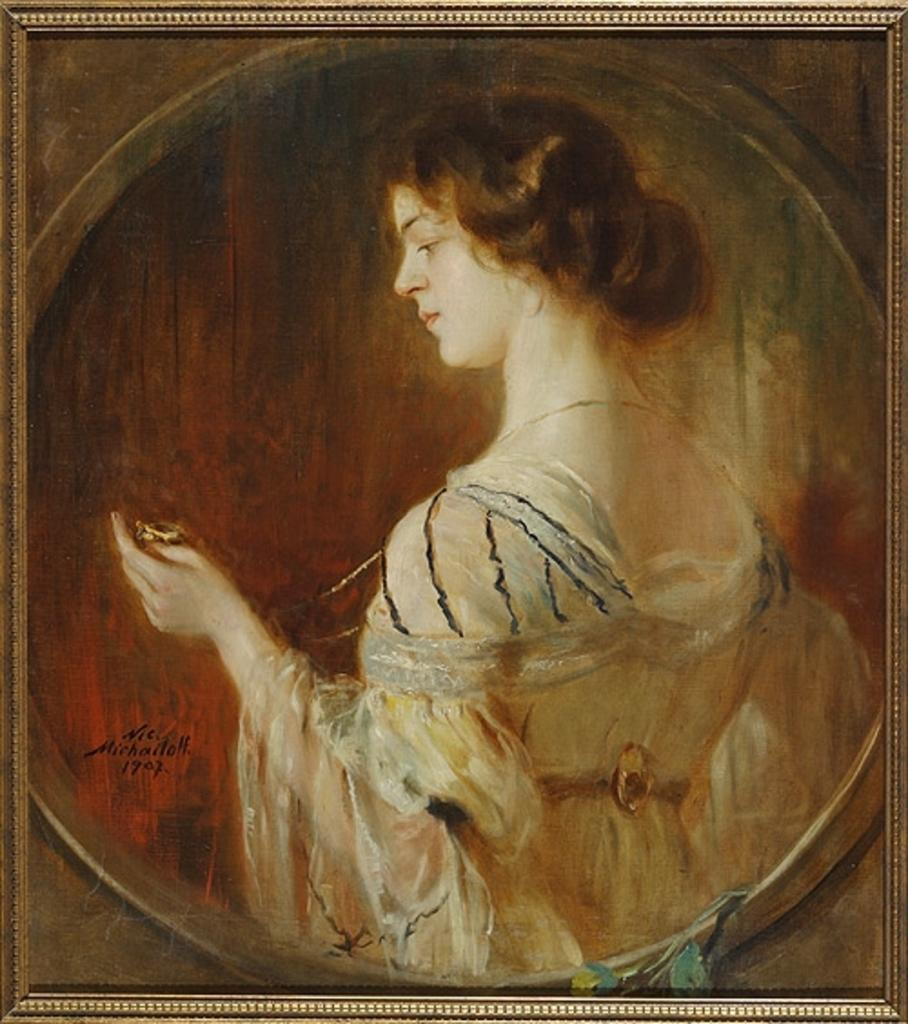What object is present in the image that typically holds a picture or artwork? There is a photo frame in the image. What is displayed within the photo frame? The photo frame contains a painting. What subject matter is depicted in the painting? The painting depicts a woman. How many geese are visible in the painting? There are no geese present in the painting; it depicts a woman. What type of vest is the woman wearing in the painting? There is no vest visible in the painting; the woman is not wearing any clothing as it is a painting. 